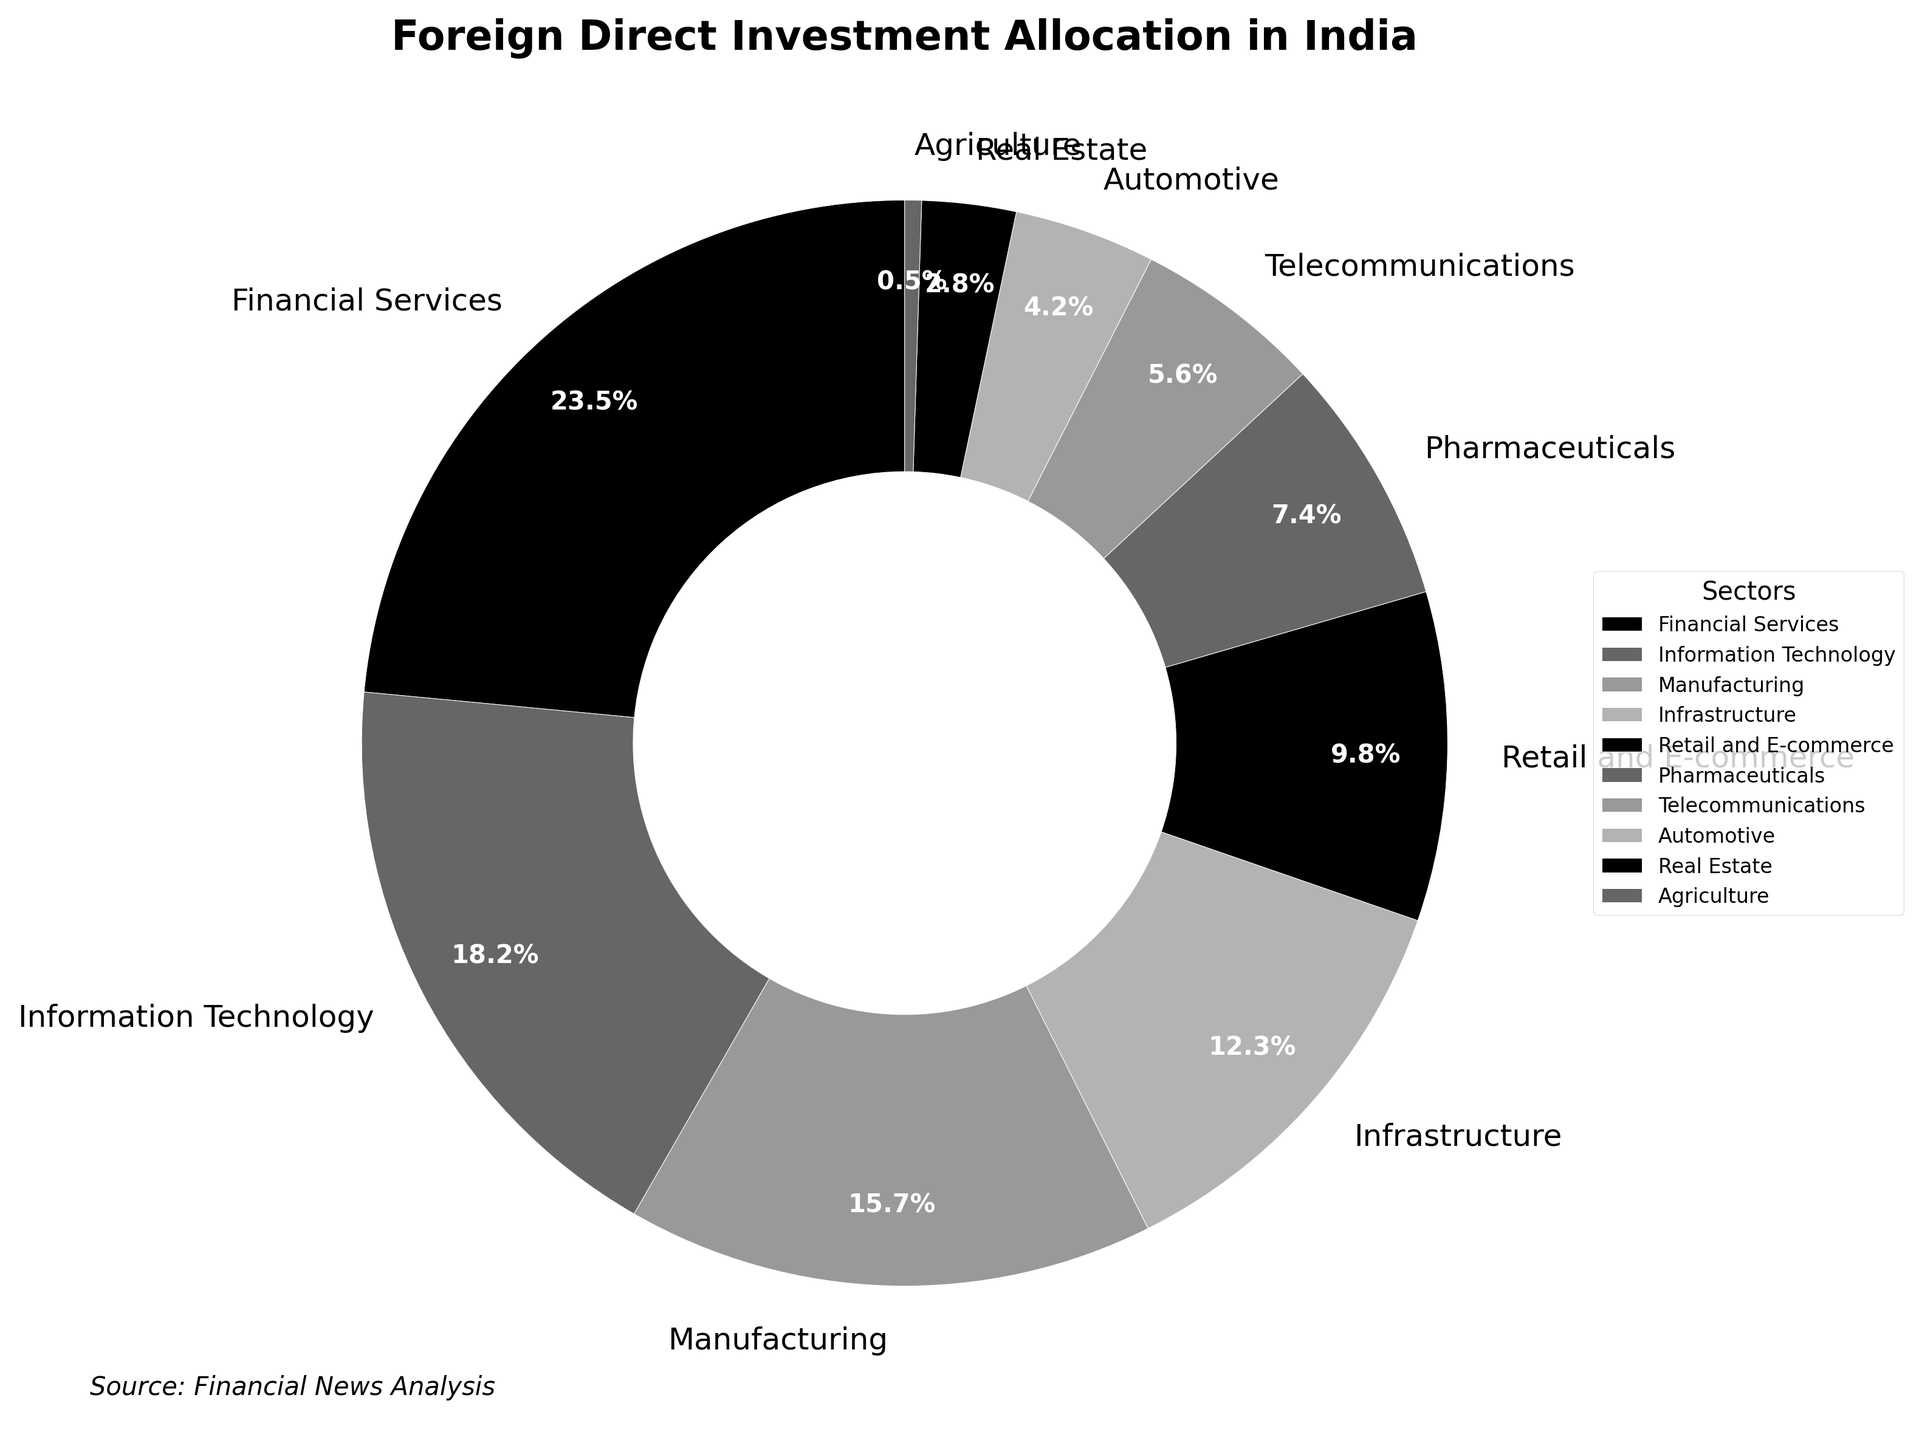Which sector receives the largest allocation of foreign direct investment? To find the sector with the largest allocation, look for the segment with the highest percentage. The Financial Services sector has 23.5%, which is the highest in the pie chart.
Answer: Financial Services Which two sectors together account for more than 40% of the FDI allocation? To answer this, we look for two sectors whose combined percentages exceed 40%. Adding the Financial Services (23.5%) and Information Technology (18.2%) results in 41.7%, which is more than 40%.
Answer: Financial Services and Information Technology How does the allocation to the Manufacturing sector compare to the allocation to the Retail and E-commerce sector? Check the percentages for both sectors. The Manufacturing sector has 15.7%, while the Retail and E-commerce sector has 9.8%. Since 15.7% is more than 9.8%, the Manufacturing sector gets more FDI.
Answer: Manufacturing sector has more What is the combined percentage of FDI allocation in Telecommunications and Agriculture sectors? Look for the percentages of Telecommunications and Agriculture, which are 5.6% and 0.5% respectively. Adding these gives a total of 6.1%.
Answer: 6.1% Is the FDI allocation in Pharmaceuticals higher, lower, or equal to that in Automotive? Compare the percentages for Pharmaceuticals (7.4%) and Automotive (4.2%). Since 7.4% is more than 4.2%, Pharmaceuticals receive a higher allocation.
Answer: Higher What is the smallest sector in terms of FDI allocation and its percentage? Identify the sector with the smallest slice in the pie chart. Agriculture has the smallest percentage at 0.5%.
Answer: Agriculture, 0.5% Which sector has nearly twice the FDI allocation of Real Estate? Find the percentage for Real Estate (2.8%) and search for a sector that is close to twice that. Telecommunications (5.6%) is approximately twice (2 x 2.8% = 5.6%).
Answer: Telecommunications If you combine the FDI of Infrastructure and Pharmaceuticals, how does it compare to Financial Services? Add the percentages for Infrastructure (12.3%) and Pharmaceuticals (7.4%) to get 19.7%. Compare this to Financial Services (23.5%). Since 19.7% is less than 23.5%, the combined FDI of these two sectors is less than Financial Services.
Answer: Less How much more FDI is allocated to Information Technology compared to Agriculture? Subtract the percentage of Agriculture (0.5%) from Information Technology (18.2%). The result is 18.2% - 0.5% = 17.7%.
Answer: 17.7% Which sector receives less than 10% but more than 5% of the FDI allocation? Identify sectors with percentages between 5% and 10%. Telecommunications has 5.6%, which fits this range.
Answer: Telecommunications 